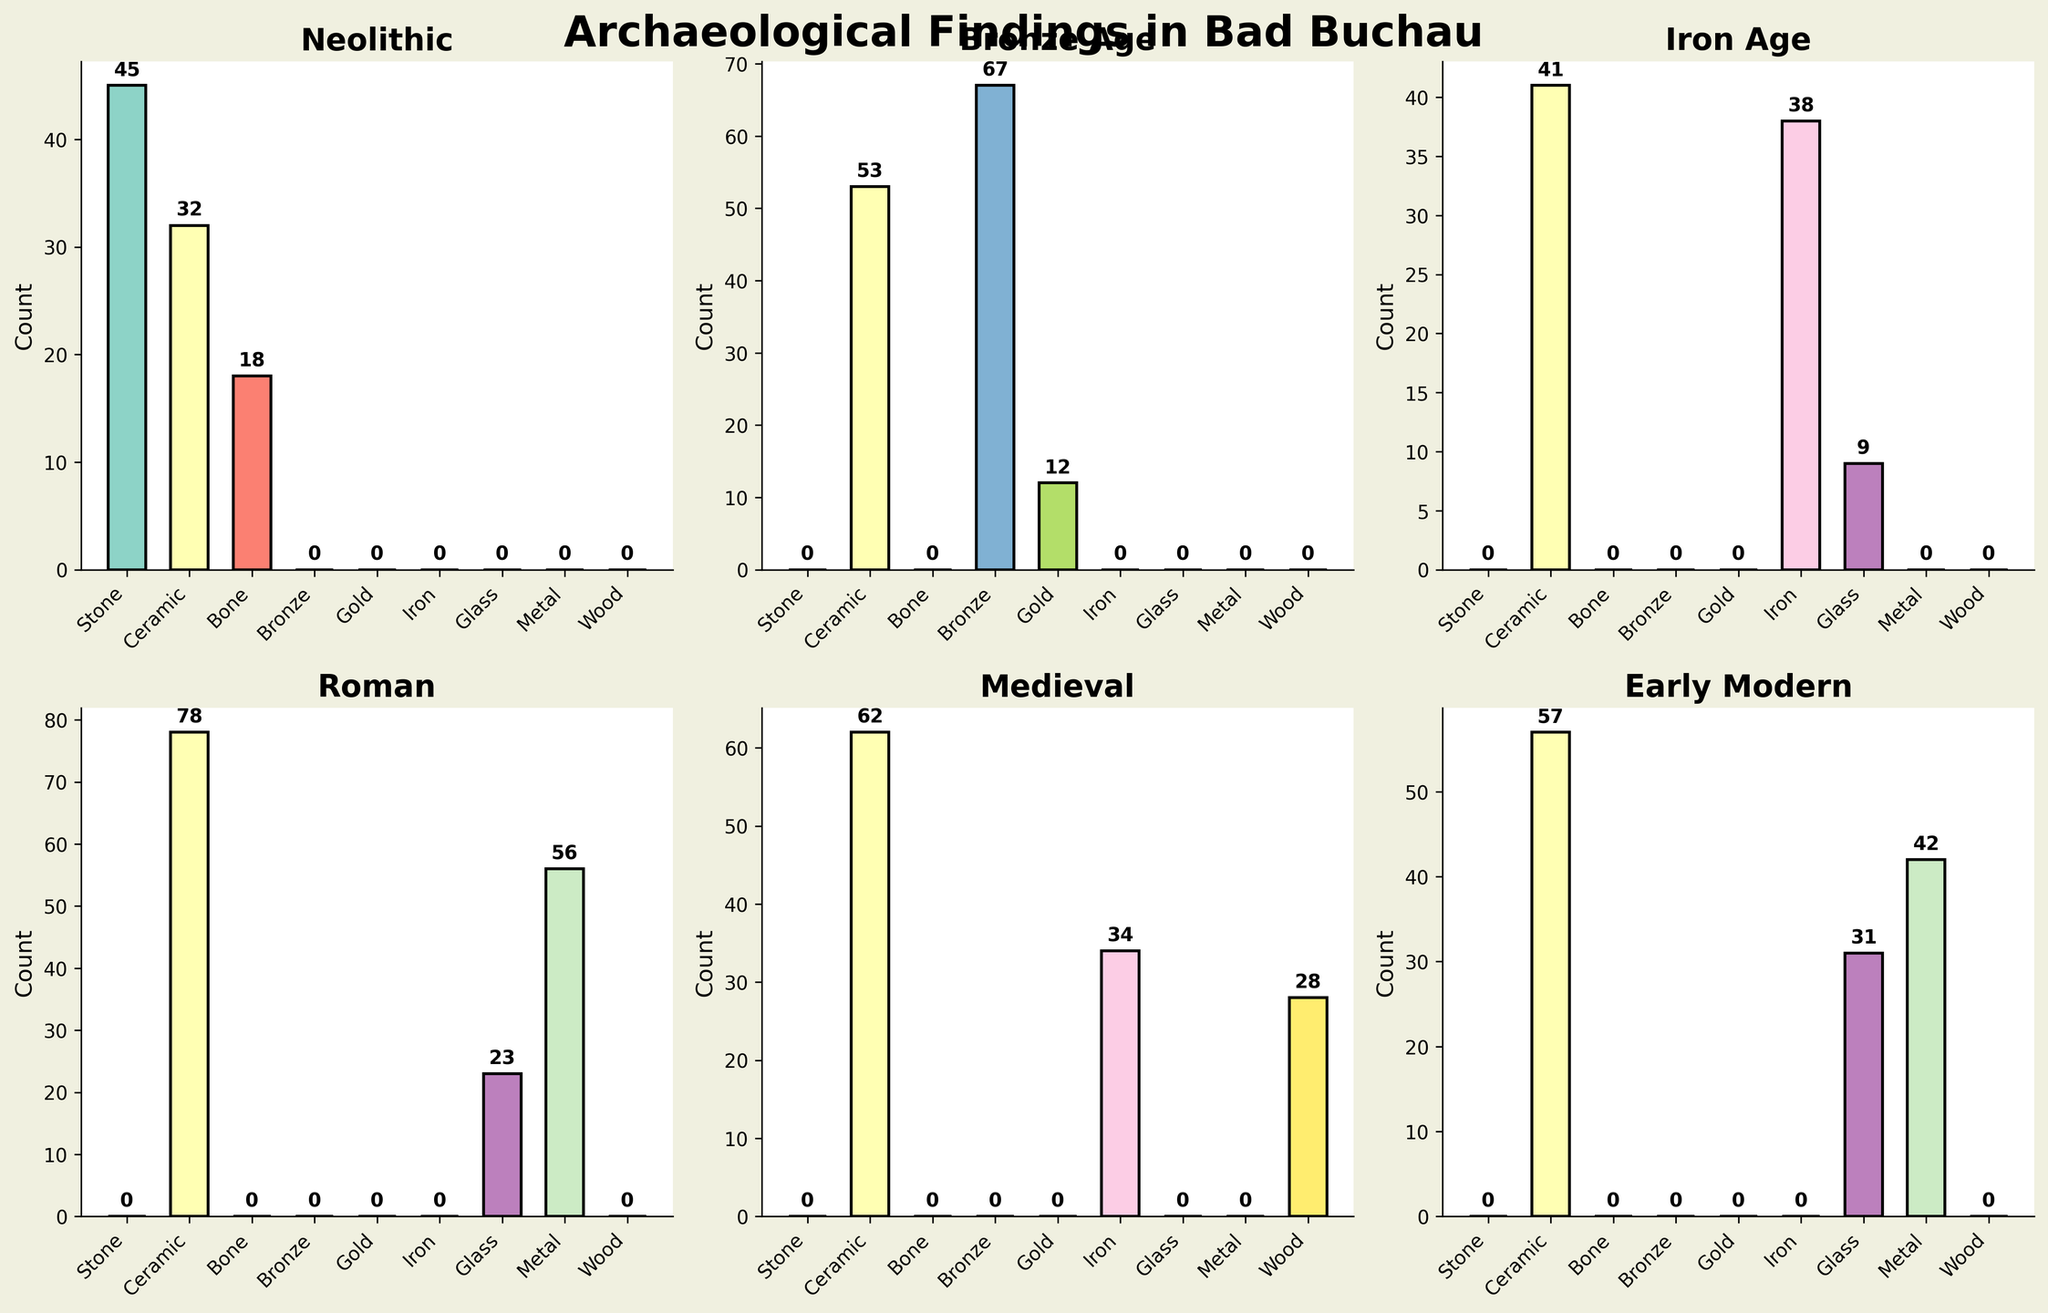Which historical period has the highest count of Ceramic findings? Look at the Ceramic bars in each subplot and identify the highest count. The Roman period shows 78 Ceramic findings.
Answer: Roman How many Bone findings are there in the Neolithic period? Locate the Neolithic subplot and check the count for the Bone bar. The annotated number shows 18.
Answer: 18 Compare the total counts of Metal findings between the Roman and Early Modern periods. Which period has more? Add the counts of Metal findings in both the Roman (56) and Early Modern (42) subplots. The Roman period has more, with a total of 56 compared to 42 in the Early Modern period.
Answer: Roman What’s the combined total of Ceramic and Glass findings in the Iron Age? Sum the annotated counts for Ceramic (41) and Glass (9) in the Iron Age subplot. The combined total is 41 + 9 = 50.
Answer: 50 Which material has the highest variability in count across all periods? Compare the range of counts for each material type across all subplots. Ceramic is found in all subplots and shows high variability, with counts ranging from 32 to 78.
Answer: Ceramic During the Bronze Age, how does the count of Bronze findings compare to that of Ceramic findings? Compare the heights of the Bronze (67) and Ceramic (53) bars in the Bronze Age subplot. The count for Bronze is higher.
Answer: Bronze In which historical period is Glass found the most frequently? Locate the Glass bars in every subplot and compare their heights. The highest Glass count, 31, is found in the Early Modern period.
Answer: Early Modern What's the total number of Iron findings across all periods? Sum the counts of Iron findings in the Iron Age (38) and Medieval (34) subplots. The total is 38 + 34 = 72.
Answer: 72 Does the Medieval period have more Wood or Iron findings? Compare the heights of the Wood (28) and Iron (34) bars in the Medieval subplot. The Iron count is higher.
Answer: Iron Which historical period has the least diverse materials found? Count the number of different materials in each subplot. The Bronze Age has the fewest unique materials with three types: Bronze, Gold, and Ceramic.
Answer: Bronze Age 